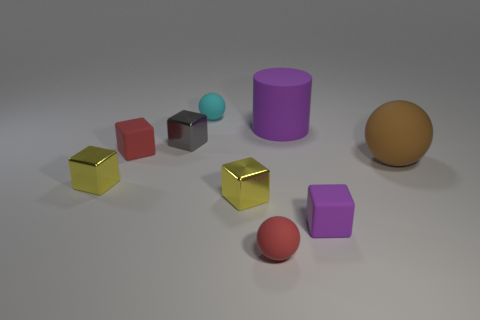There is a yellow thing on the right side of the red matte object that is behind the small shiny cube on the left side of the gray cube; how big is it?
Ensure brevity in your answer.  Small. Is the size of the cyan matte thing the same as the red object that is on the left side of the cyan rubber thing?
Offer a terse response. Yes. There is a small ball that is to the left of the red matte sphere; what color is it?
Your answer should be very brief. Cyan. There is a rubber thing that is the same color as the matte cylinder; what is its shape?
Provide a succinct answer. Cube. There is a small yellow metal thing on the left side of the tiny red rubber cube; what shape is it?
Offer a terse response. Cube. How many gray objects are shiny cubes or blocks?
Provide a short and direct response. 1. Is the purple block made of the same material as the cyan sphere?
Your response must be concise. Yes. How many yellow shiny blocks are in front of the large purple cylinder?
Ensure brevity in your answer.  2. There is a tiny cube that is both left of the tiny cyan rubber ball and in front of the brown object; what is its material?
Offer a very short reply. Metal. What number of balls are either tiny yellow objects or large brown objects?
Make the answer very short. 1. 